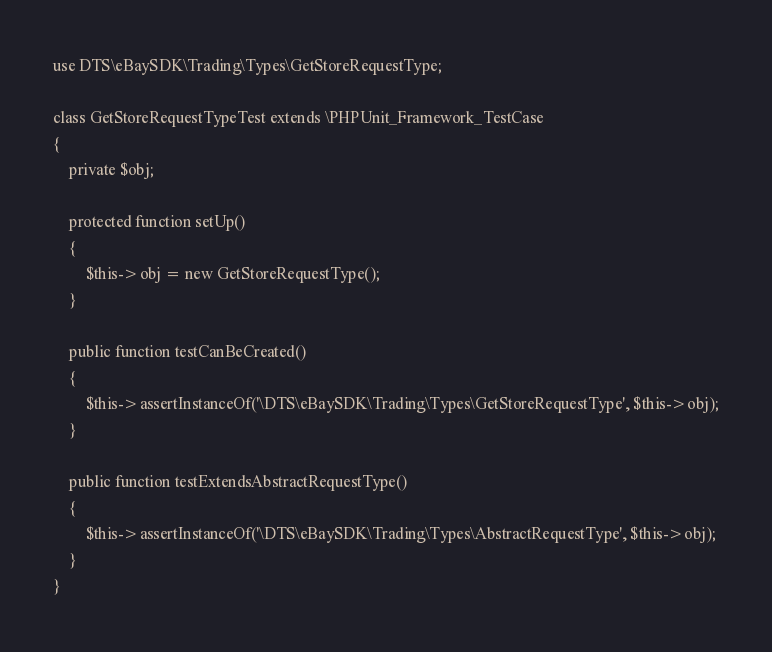<code> <loc_0><loc_0><loc_500><loc_500><_PHP_>use DTS\eBaySDK\Trading\Types\GetStoreRequestType;

class GetStoreRequestTypeTest extends \PHPUnit_Framework_TestCase
{
    private $obj;

    protected function setUp()
    {
        $this->obj = new GetStoreRequestType();
    }

    public function testCanBeCreated()
    {
        $this->assertInstanceOf('\DTS\eBaySDK\Trading\Types\GetStoreRequestType', $this->obj);
    }

    public function testExtendsAbstractRequestType()
    {
        $this->assertInstanceOf('\DTS\eBaySDK\Trading\Types\AbstractRequestType', $this->obj);
    }
}
</code> 